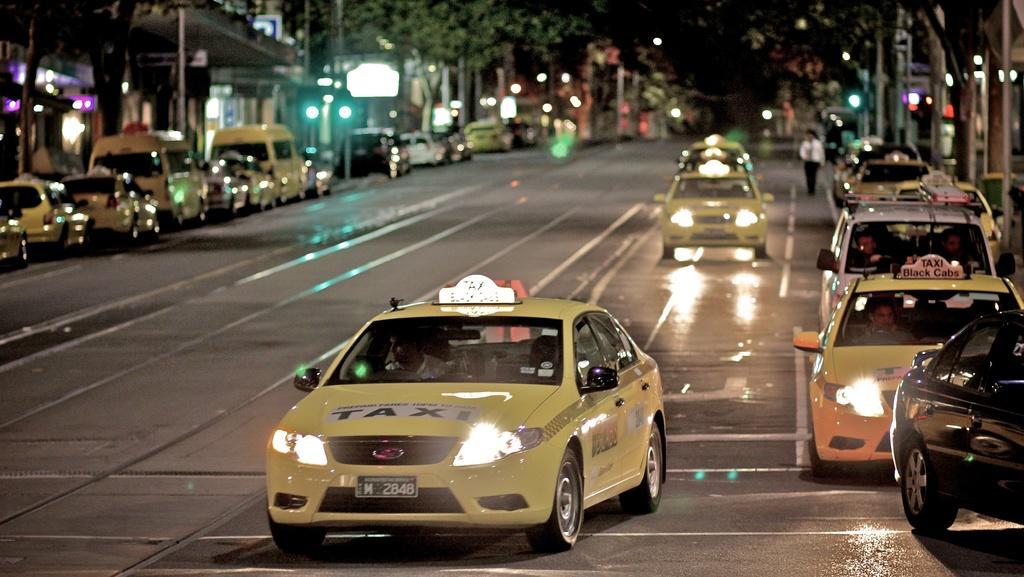Please provide a concise description of this image. In this picture we can see few vehicles on the road, in the background we can find few buildings, hoardings, poles, lights and trees, on the right side of the image we can see a person is walking on the road. 